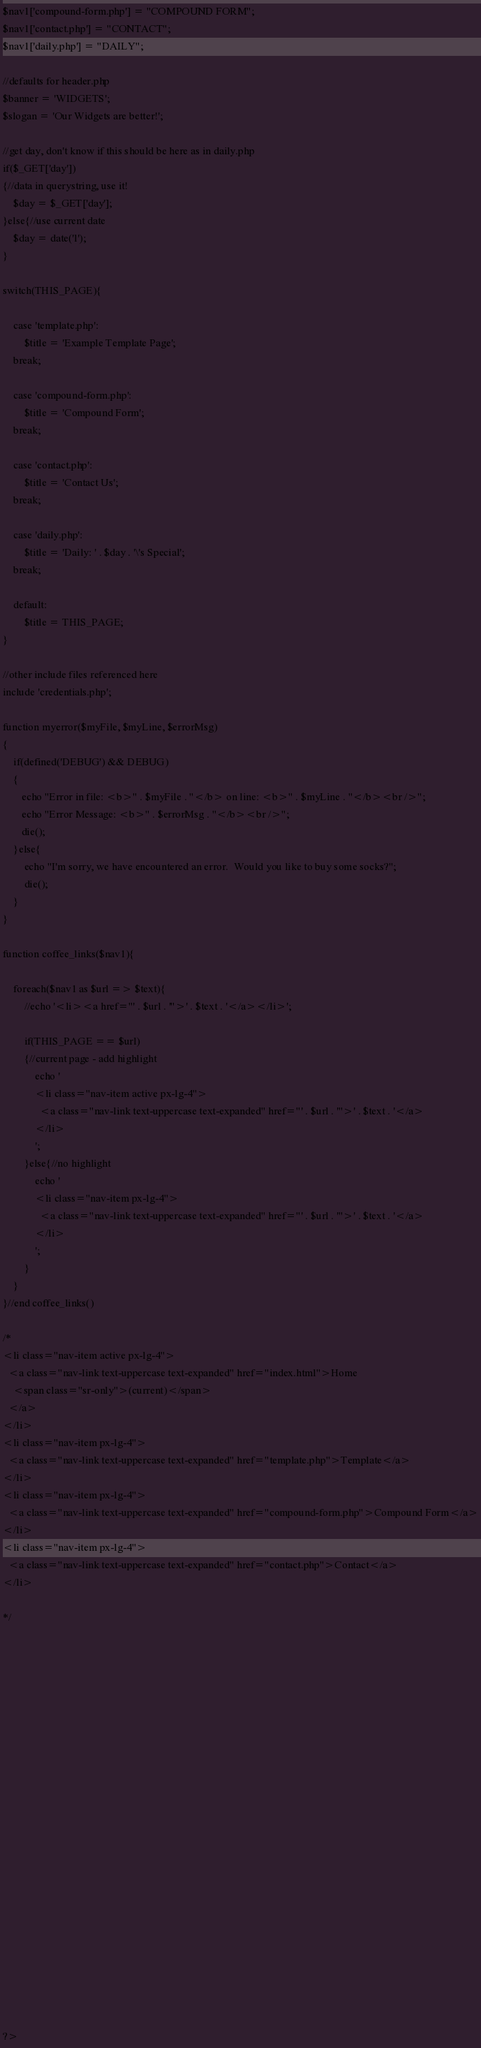<code> <loc_0><loc_0><loc_500><loc_500><_PHP_>$nav1['compound-form.php'] = "COMPOUND FORM";
$nav1['contact.php'] = "CONTACT";
$nav1['daily.php'] = "DAILY";

//defaults for header.php
$banner = 'WIDGETS';
$slogan = 'Our Widgets are better!';

//get day, don't know if this should be here as in daily.php
if($_GET['day'])
{//data in querystring, use it!
    $day = $_GET['day'];
}else{//use current date
    $day = date('l');
}

switch(THIS_PAGE){
    
    case 'template.php':
        $title = 'Example Template Page';
    break;
        
    case 'compound-form.php':
        $title = 'Compound Form';
    break;
        
    case 'contact.php':
        $title = 'Contact Us';
    break;
        
    case 'daily.php':
        $title = 'Daily: ' . $day . '\'s Special';
    break;
        
    default:
        $title = THIS_PAGE;
}

//other include files referenced here
include 'credentials.php';

function myerror($myFile, $myLine, $errorMsg)
{
    if(defined('DEBUG') && DEBUG)
    {
       echo "Error in file: <b>" . $myFile . "</b> on line: <b>" . $myLine . "</b><br />";
       echo "Error Message: <b>" . $errorMsg . "</b><br />";
       die();
    }else{
		echo "I'm sorry, we have encountered an error.  Would you like to buy some socks?";
		die();
    }
}

function coffee_links($nav1){
    
    foreach($nav1 as $url => $text){
        //echo '<li><a href="' . $url . '">' . $text . '</a></li>';
        
        if(THIS_PAGE == $url)
        {//current page - add highlight
            echo '
            <li class="nav-item active px-lg-4">
              <a class="nav-link text-uppercase text-expanded" href="' . $url . '">' . $text . '</a>
            </li>
            ';
        }else{//no highlight
            echo '
            <li class="nav-item px-lg-4">
              <a class="nav-link text-uppercase text-expanded" href="' . $url . '">' . $text . '</a>
            </li>
            ';
        }
    }
}//end coffee_links()

/*
<li class="nav-item active px-lg-4">
  <a class="nav-link text-uppercase text-expanded" href="index.html">Home
    <span class="sr-only">(current)</span>
  </a>
</li>
<li class="nav-item px-lg-4">
  <a class="nav-link text-uppercase text-expanded" href="template.php">Template</a>
</li>
<li class="nav-item px-lg-4">
  <a class="nav-link text-uppercase text-expanded" href="compound-form.php">Compound Form</a>
</li>
<li class="nav-item px-lg-4">
  <a class="nav-link text-uppercase text-expanded" href="contact.php">Contact</a>
</li>

*/























?></code> 